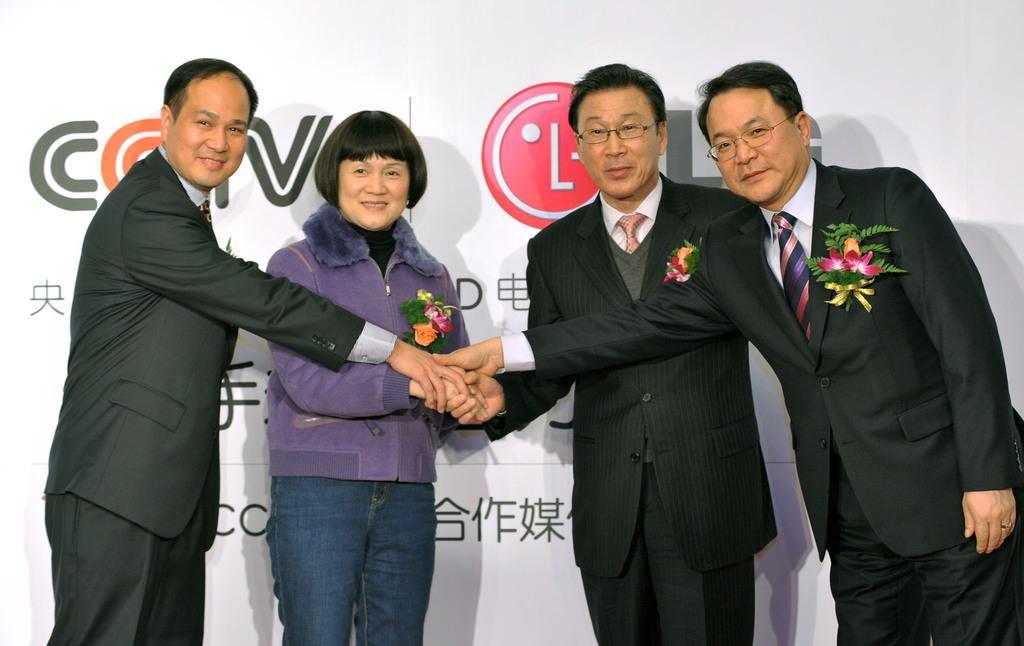Please provide a concise description of this image. There are people holding flowers in their hands in the foreground area of the image, there is text on the poster in the background. 